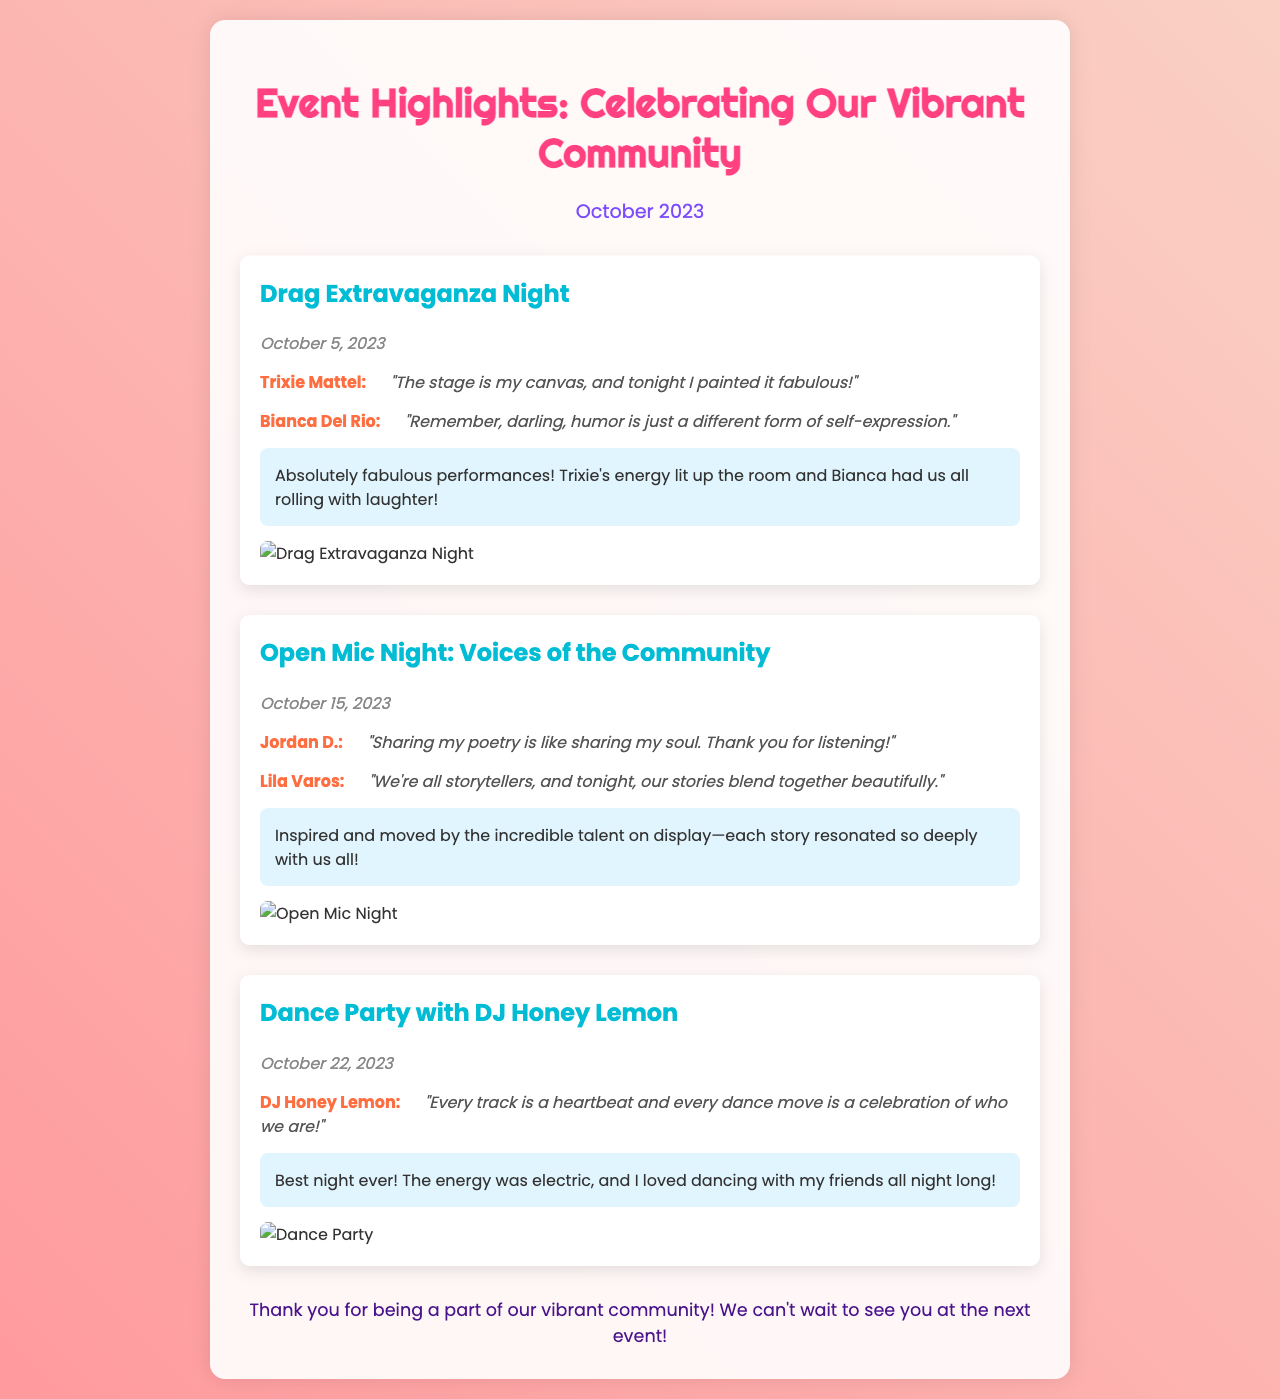what was the date of the Drag Extravaganza Night? The date is provided in the document, under the section of the Drag Extravaganza Night.
Answer: October 5, 2023 who performed at the Open Mic Night? The document lists the performers for the Open Mic Night event.
Answer: Jordan D., Lila Varos what was DJ Honey Lemon's quote during the Dance Party? The quote is mentioned directly under DJ Honey Lemon's name in the event details.
Answer: "Every track is a heartbeat and every dance move is a celebration of who we are!" how many events are highlighted in the newsletter? By counting the events described in the document, we can determine the total number of highlighted events.
Answer: 3 what type of event took place on October 15, 2023? The document specifies the event that occurred on this date.
Answer: Open Mic Night: Voices of the Community who was the performer featured at the Drag Extravaganza Night? The document provides the names of the performers featured during the Drag Extravaganza Night.
Answer: Trixie Mattel, Bianca Del Rio what was the audience feedback for the Dance Party? Audience feedback is summarized following the details of the Dance Party.
Answer: Best night ever! The energy was electric, and I loved dancing with my friends all night long! what is the title of the newsletter? The title is stated at the top of the document.
Answer: Event Highlights: Celebrating Our Vibrant Community 